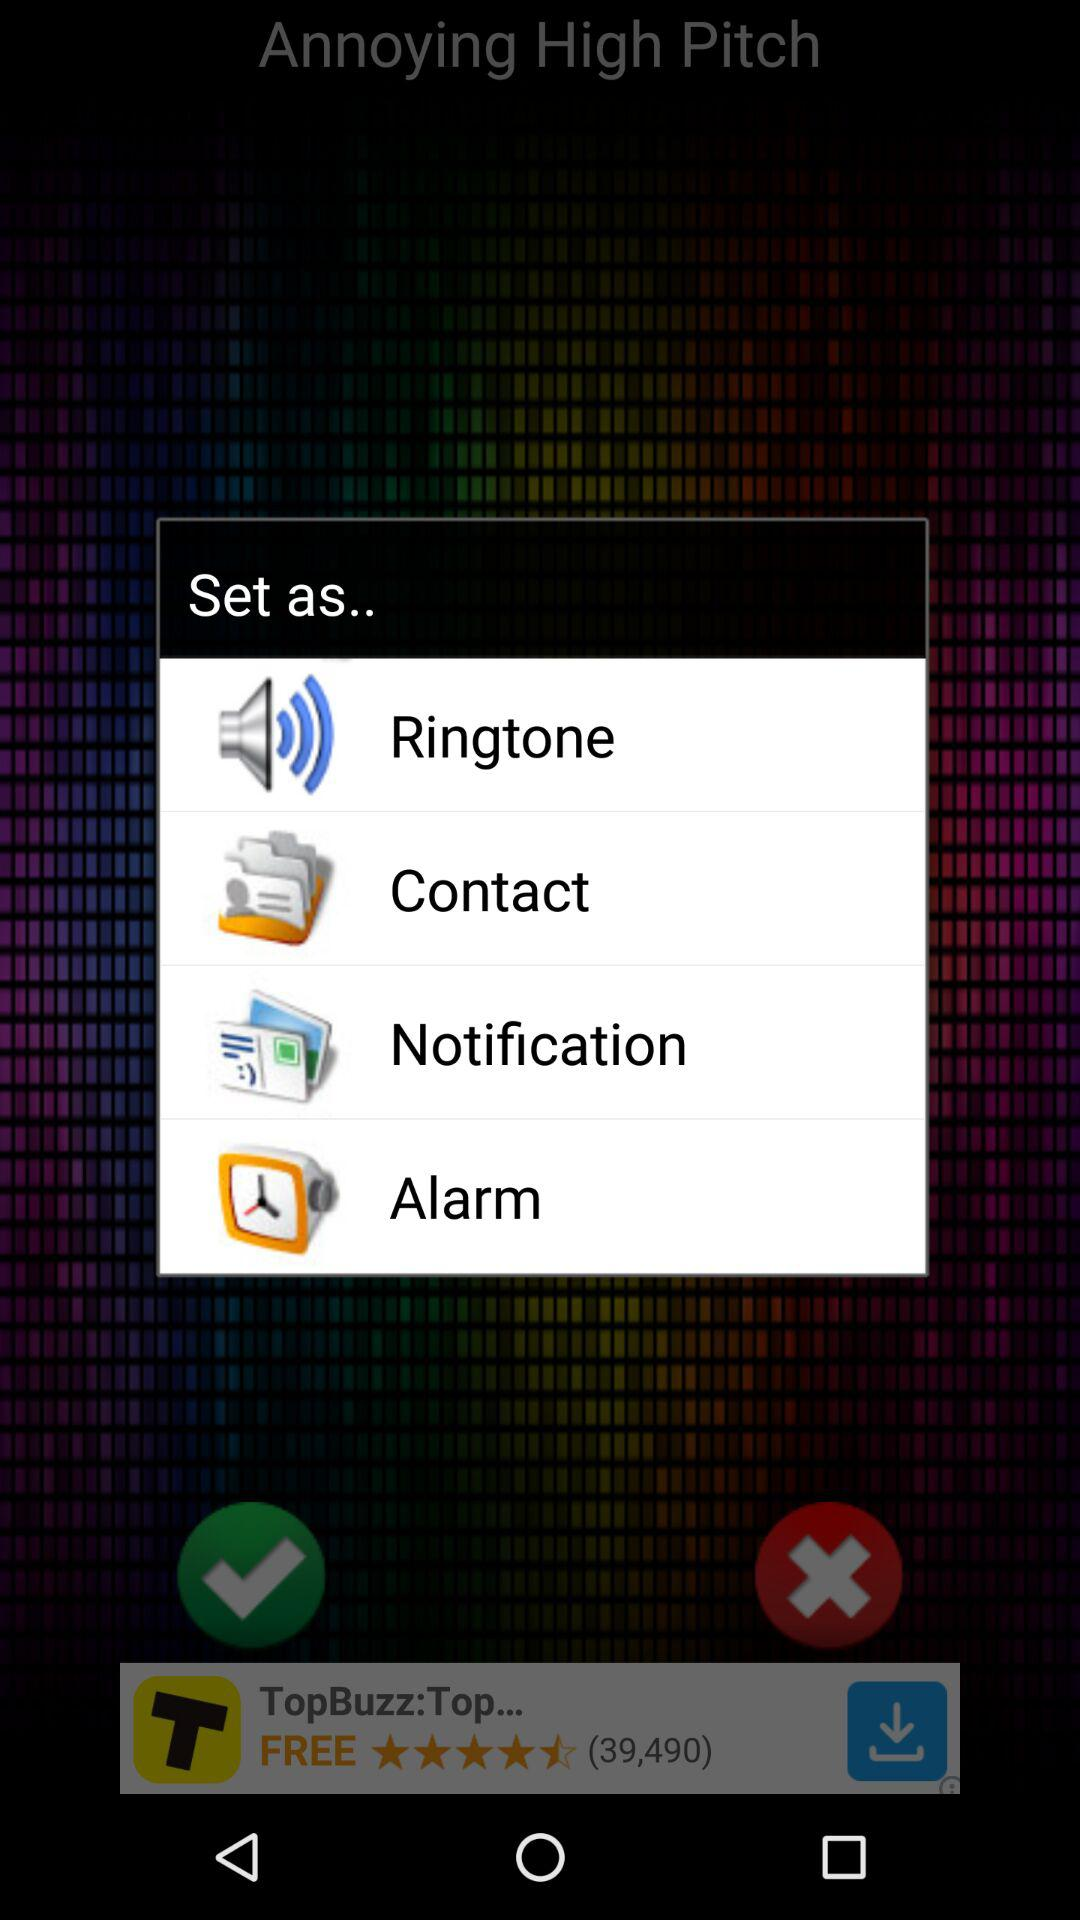How many apps are available?
When the provided information is insufficient, respond with <no answer>. <no answer> 